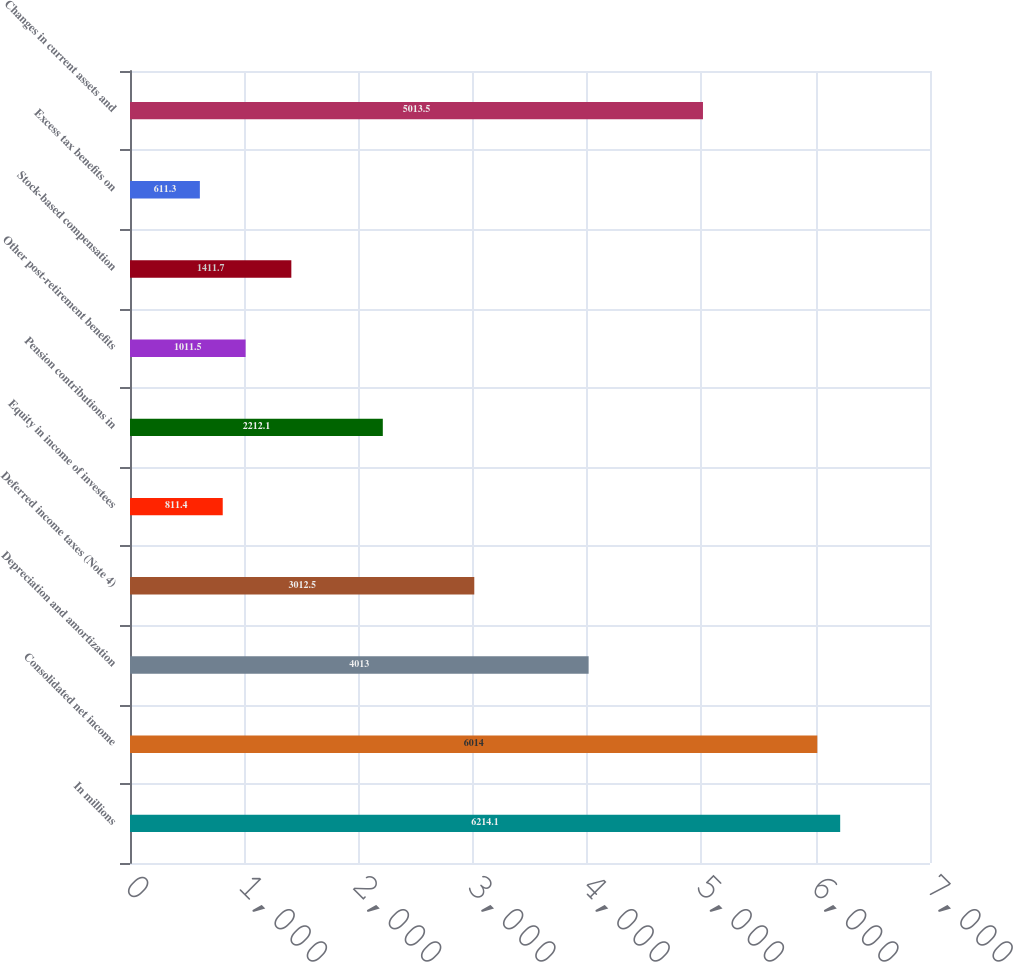Convert chart to OTSL. <chart><loc_0><loc_0><loc_500><loc_500><bar_chart><fcel>In millions<fcel>Consolidated net income<fcel>Depreciation and amortization<fcel>Deferred income taxes (Note 4)<fcel>Equity in income of investees<fcel>Pension contributions in<fcel>Other post-retirement benefits<fcel>Stock-based compensation<fcel>Excess tax benefits on<fcel>Changes in current assets and<nl><fcel>6214.1<fcel>6014<fcel>4013<fcel>3012.5<fcel>811.4<fcel>2212.1<fcel>1011.5<fcel>1411.7<fcel>611.3<fcel>5013.5<nl></chart> 